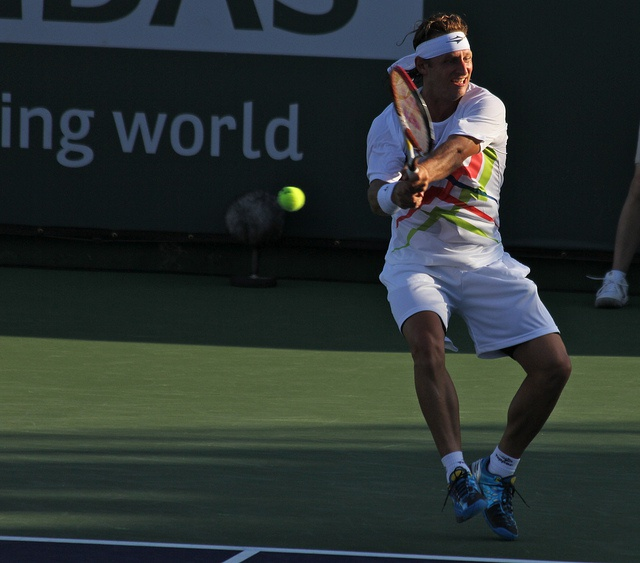Describe the objects in this image and their specific colors. I can see people in black, gray, and lightgray tones, tennis racket in black, gray, and maroon tones, people in black, blue, gray, and darkblue tones, and sports ball in black, darkgreen, yellow, and green tones in this image. 